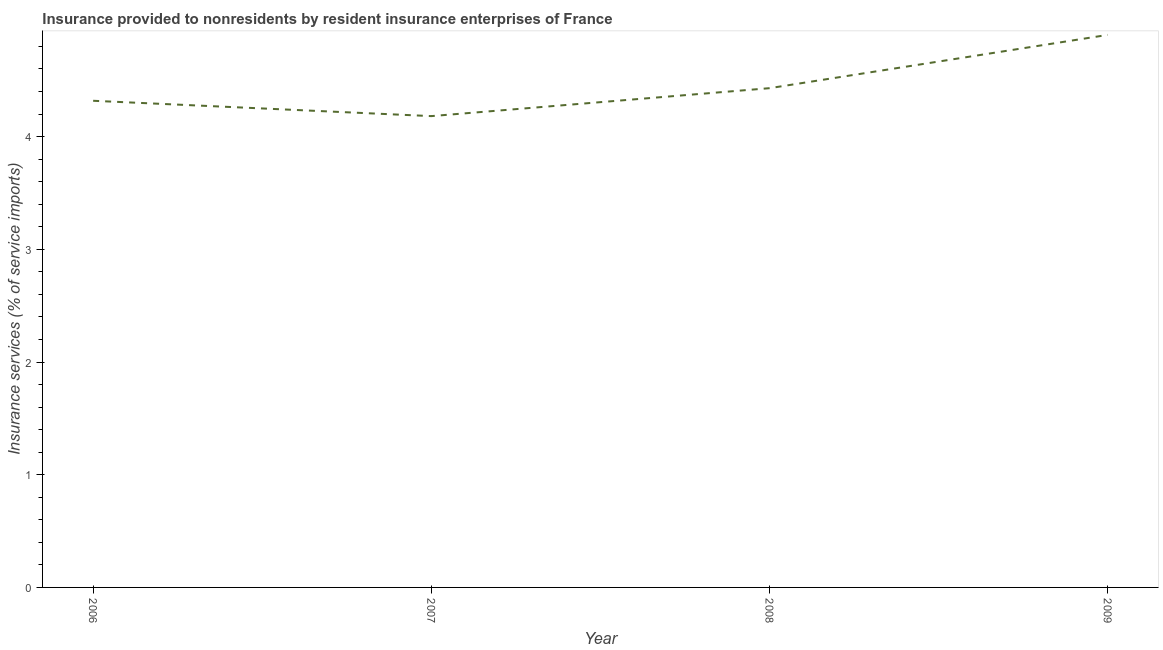What is the insurance and financial services in 2008?
Offer a terse response. 4.43. Across all years, what is the maximum insurance and financial services?
Offer a terse response. 4.9. Across all years, what is the minimum insurance and financial services?
Your answer should be very brief. 4.18. What is the sum of the insurance and financial services?
Provide a short and direct response. 17.83. What is the difference between the insurance and financial services in 2008 and 2009?
Keep it short and to the point. -0.47. What is the average insurance and financial services per year?
Your answer should be very brief. 4.46. What is the median insurance and financial services?
Your response must be concise. 4.37. Do a majority of the years between 2009 and 2007 (inclusive) have insurance and financial services greater than 4.2 %?
Your response must be concise. No. What is the ratio of the insurance and financial services in 2007 to that in 2009?
Your response must be concise. 0.85. Is the insurance and financial services in 2006 less than that in 2007?
Your answer should be compact. No. What is the difference between the highest and the second highest insurance and financial services?
Provide a succinct answer. 0.47. Is the sum of the insurance and financial services in 2006 and 2009 greater than the maximum insurance and financial services across all years?
Provide a short and direct response. Yes. What is the difference between the highest and the lowest insurance and financial services?
Give a very brief answer. 0.72. In how many years, is the insurance and financial services greater than the average insurance and financial services taken over all years?
Ensure brevity in your answer.  1. Does the insurance and financial services monotonically increase over the years?
Keep it short and to the point. No. What is the difference between two consecutive major ticks on the Y-axis?
Give a very brief answer. 1. Are the values on the major ticks of Y-axis written in scientific E-notation?
Keep it short and to the point. No. Does the graph contain grids?
Give a very brief answer. No. What is the title of the graph?
Keep it short and to the point. Insurance provided to nonresidents by resident insurance enterprises of France. What is the label or title of the Y-axis?
Provide a short and direct response. Insurance services (% of service imports). What is the Insurance services (% of service imports) in 2006?
Your answer should be compact. 4.32. What is the Insurance services (% of service imports) in 2007?
Give a very brief answer. 4.18. What is the Insurance services (% of service imports) of 2008?
Provide a short and direct response. 4.43. What is the Insurance services (% of service imports) in 2009?
Offer a terse response. 4.9. What is the difference between the Insurance services (% of service imports) in 2006 and 2007?
Keep it short and to the point. 0.14. What is the difference between the Insurance services (% of service imports) in 2006 and 2008?
Your response must be concise. -0.11. What is the difference between the Insurance services (% of service imports) in 2006 and 2009?
Keep it short and to the point. -0.58. What is the difference between the Insurance services (% of service imports) in 2007 and 2008?
Offer a terse response. -0.25. What is the difference between the Insurance services (% of service imports) in 2007 and 2009?
Ensure brevity in your answer.  -0.72. What is the difference between the Insurance services (% of service imports) in 2008 and 2009?
Provide a short and direct response. -0.47. What is the ratio of the Insurance services (% of service imports) in 2006 to that in 2007?
Offer a very short reply. 1.03. What is the ratio of the Insurance services (% of service imports) in 2006 to that in 2008?
Keep it short and to the point. 0.97. What is the ratio of the Insurance services (% of service imports) in 2006 to that in 2009?
Your response must be concise. 0.88. What is the ratio of the Insurance services (% of service imports) in 2007 to that in 2008?
Provide a short and direct response. 0.94. What is the ratio of the Insurance services (% of service imports) in 2007 to that in 2009?
Give a very brief answer. 0.85. What is the ratio of the Insurance services (% of service imports) in 2008 to that in 2009?
Your response must be concise. 0.9. 